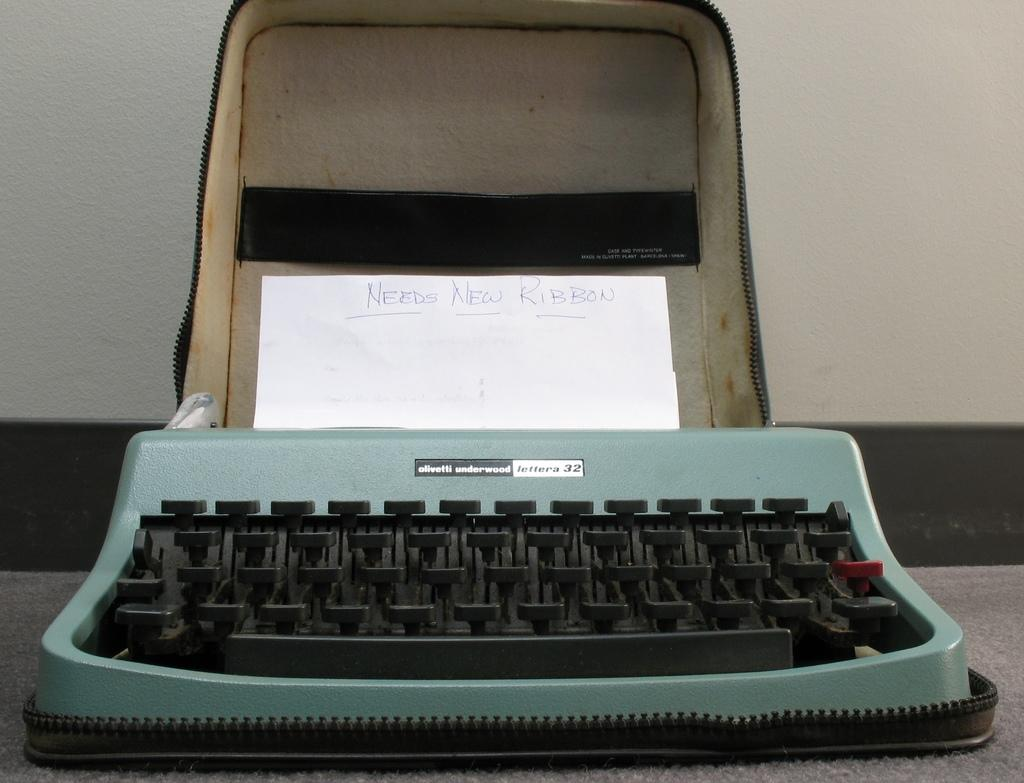<image>
Give a short and clear explanation of the subsequent image. A green typewriter that needs a new ribbon. 